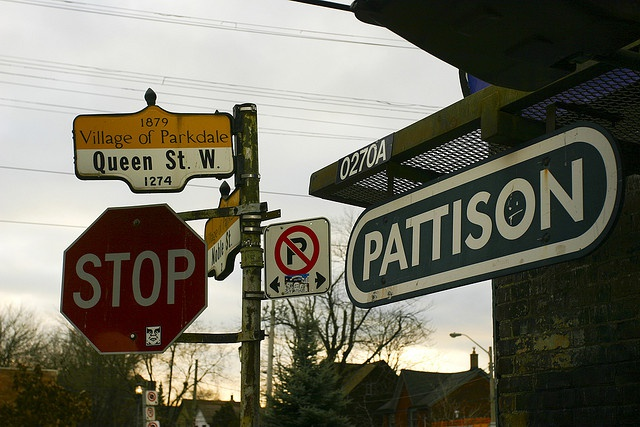Describe the objects in this image and their specific colors. I can see a stop sign in lightgray, black, gray, darkgreen, and maroon tones in this image. 